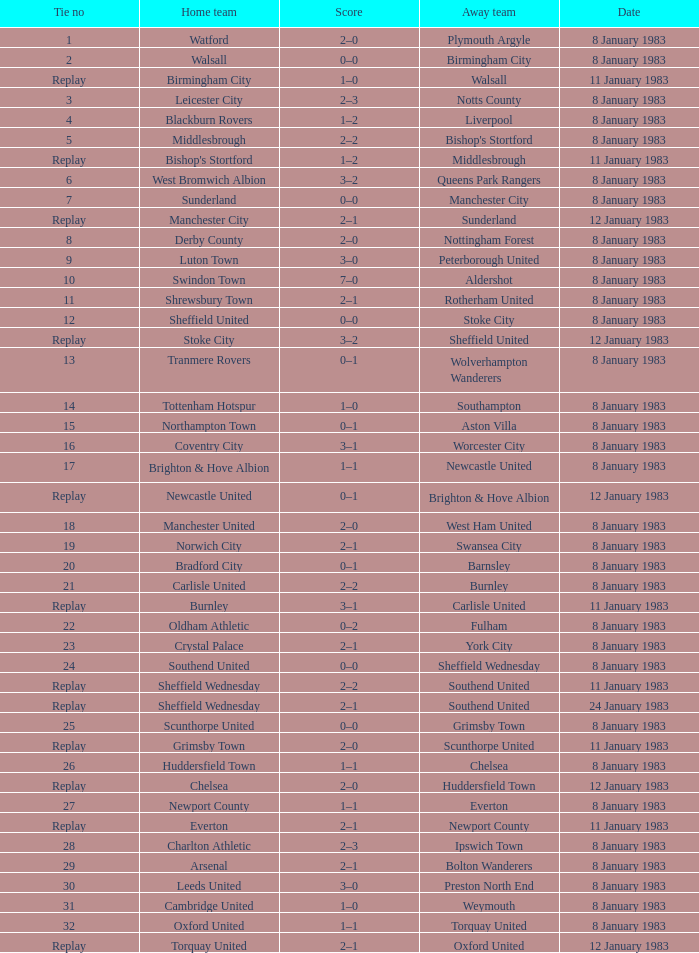During which game did scunthorpe united play as the away team? Replay. 